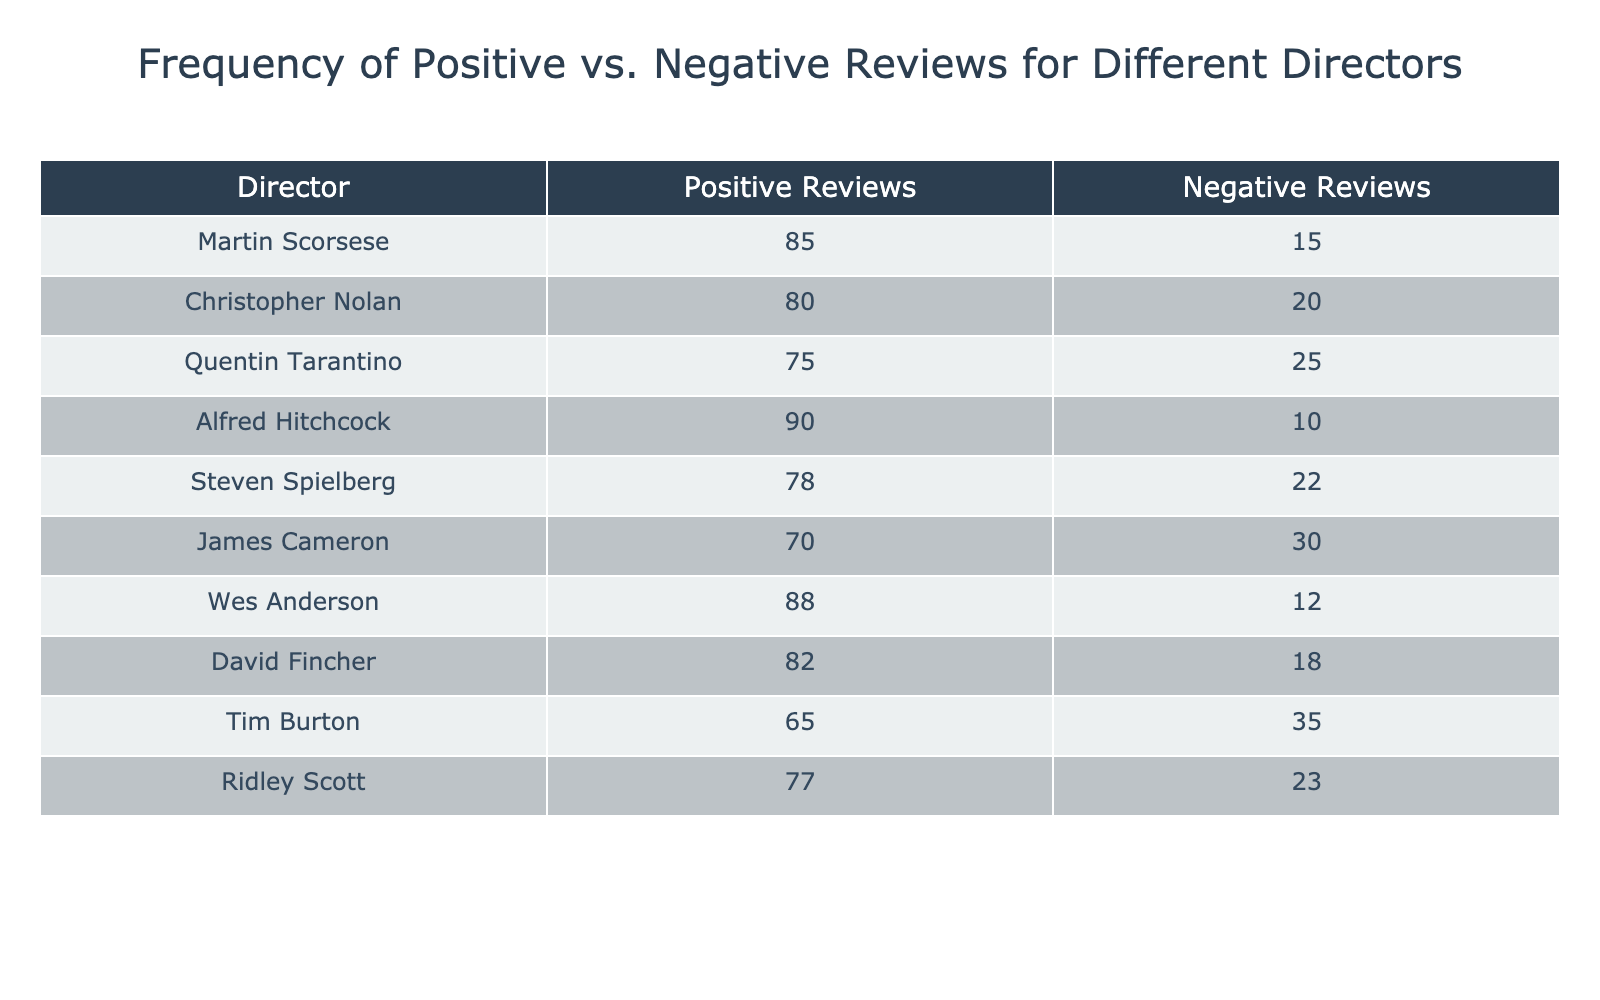What is the total number of positive reviews across all directors? To find the total number of positive reviews, I will sum the values in the "Positive Reviews" column: 85 (Scorsese) + 80 (Nolan) + 75 (Tarantino) + 90 (Hitchcock) + 78 (Spielberg) + 70 (Cameron) + 88 (Anderson) + 82 (Fincher) + 65 (Burton) + 77 (Scott) =  85 + 80 + 75 + 90 + 78 + 70 + 88 + 82 + 65 + 77 =  810.
Answer: 810 Which director has the highest number of negative reviews? I will compare the "Negative Reviews" values of all directors to determine the highest number: 15 (Scorsese), 20 (Nolan), 25 (Tarantino), 10 (Hitchcock), 22 (Spielberg), 30 (Cameron), 12 (Anderson), 18 (Fincher), 35 (Burton), and 23 (Scott). Tim Burton has the highest with 35 negative reviews.
Answer: Tim Burton What is the difference between positive and negative reviews for David Fincher? I will calculate the difference by subtracting the number of negative reviews from the number of positive reviews for David Fincher: 82 (Positive) - 18 (Negative) = 64.
Answer: 64 Is it true that Christopher Nolan has more positive reviews than Tim Burton? I will compare the positive reviews: Christopher Nolan has 80, while Tim Burton has 65. Since 80 is greater than 65, the statement is true.
Answer: Yes What is the average number of negative reviews for the directors listed? To find the average, I will sum the negative reviews: 15 + 20 + 25 + 10 + 22 + 30 + 12 + 18 + 35 + 23 =  15 + 20 + 25 + 10 + 22 + 30 + 12 + 18 + 35 + 23 =  210. Then, divide by the total number of directors, which is 10: 210 / 10 = 21.
Answer: 21 